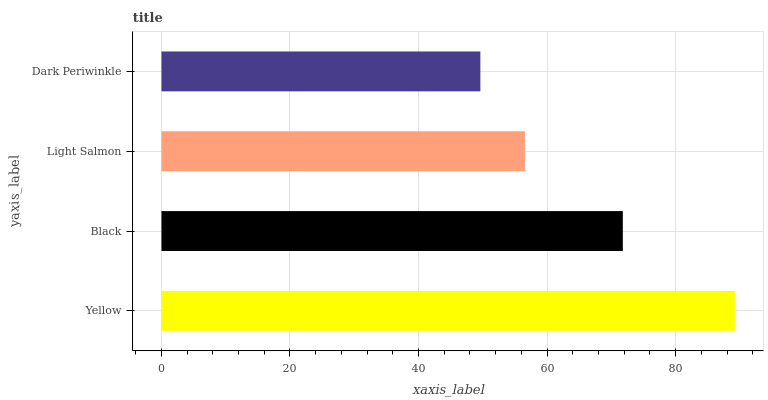Is Dark Periwinkle the minimum?
Answer yes or no. Yes. Is Yellow the maximum?
Answer yes or no. Yes. Is Black the minimum?
Answer yes or no. No. Is Black the maximum?
Answer yes or no. No. Is Yellow greater than Black?
Answer yes or no. Yes. Is Black less than Yellow?
Answer yes or no. Yes. Is Black greater than Yellow?
Answer yes or no. No. Is Yellow less than Black?
Answer yes or no. No. Is Black the high median?
Answer yes or no. Yes. Is Light Salmon the low median?
Answer yes or no. Yes. Is Yellow the high median?
Answer yes or no. No. Is Black the low median?
Answer yes or no. No. 